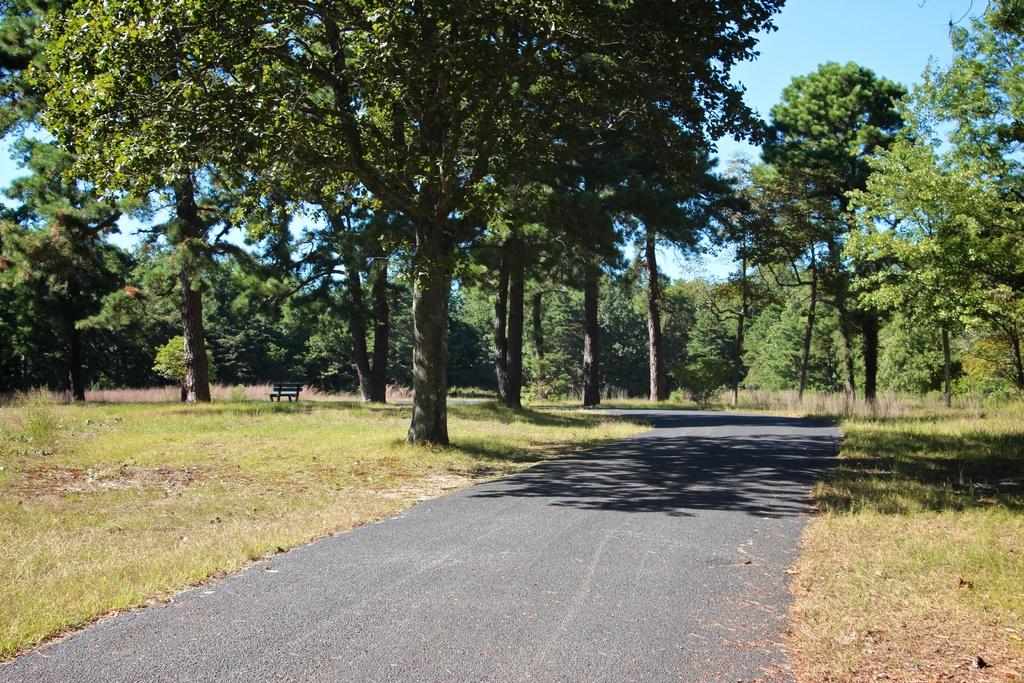What type of natural elements can be seen in the image? There are many trees and plants in the image. What man-made structure is present in the image? There is a road and a bench in the image. What is visible in the background of the image? There is a sky visible in the image. What type of zephyr can be seen flying around the trees in the image? There is no zephyr present in the image; it is a term used to describe a gentle breeze, and there is no indication of wind in the image. Can you tell me how many wrens are perched on the bench in the image? There are no wrens present in the image; it is a type of bird, and there is no mention of birds in the provided facts. 